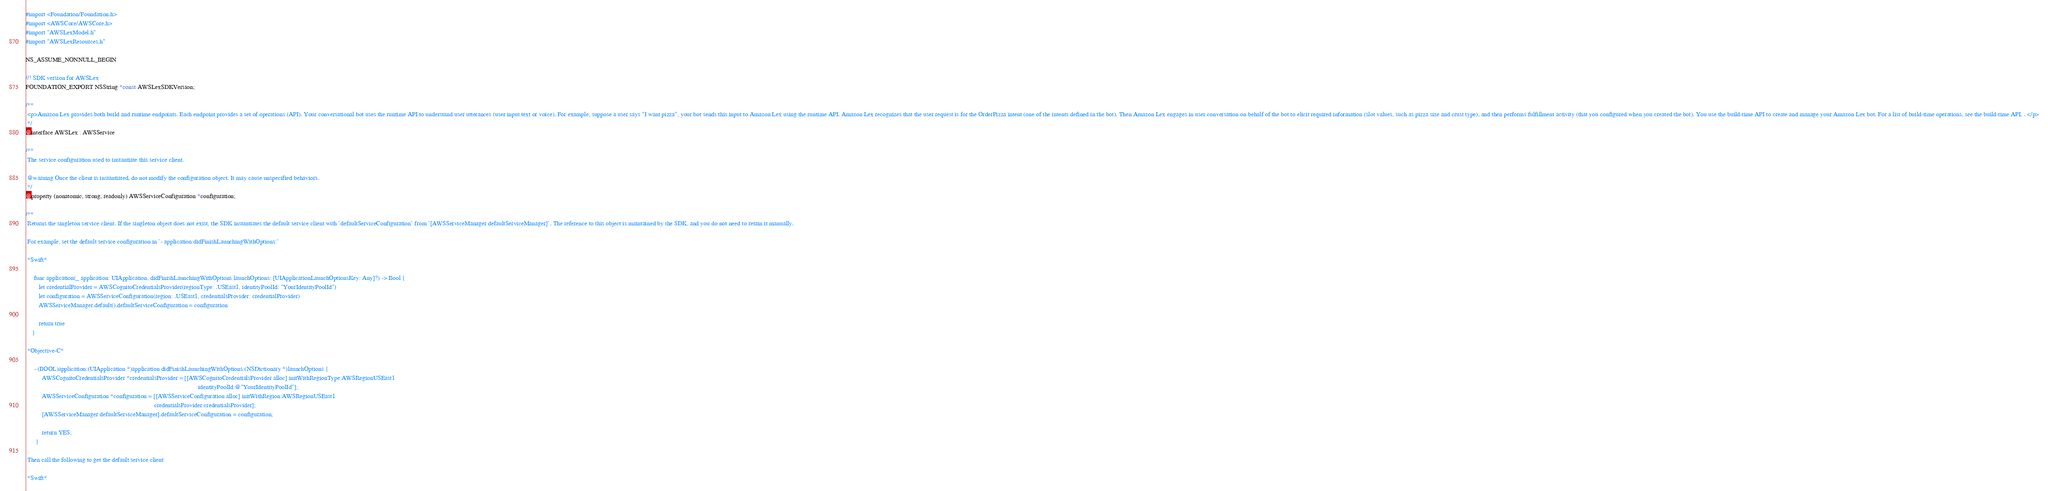Convert code to text. <code><loc_0><loc_0><loc_500><loc_500><_C_>
#import <Foundation/Foundation.h>
#import <AWSCore/AWSCore.h>
#import "AWSLexModel.h"
#import "AWSLexResources.h"

NS_ASSUME_NONNULL_BEGIN

//! SDK version for AWSLex
FOUNDATION_EXPORT NSString *const AWSLexSDKVersion;

/**
 <p>Amazon Lex provides both build and runtime endpoints. Each endpoint provides a set of operations (API). Your conversational bot uses the runtime API to understand user utterances (user input text or voice). For example, suppose a user says "I want pizza", your bot sends this input to Amazon Lex using the runtime API. Amazon Lex recognizes that the user request is for the OrderPizza intent (one of the intents defined in the bot). Then Amazon Lex engages in user conversation on behalf of the bot to elicit required information (slot values, such as pizza size and crust type), and then performs fulfillment activity (that you configured when you created the bot). You use the build-time API to create and manage your Amazon Lex bot. For a list of build-time operations, see the build-time API, . </p>
 */
@interface AWSLex : AWSService

/**
 The service configuration used to instantiate this service client.
 
 @warning Once the client is instantiated, do not modify the configuration object. It may cause unspecified behaviors.
 */
@property (nonatomic, strong, readonly) AWSServiceConfiguration *configuration;

/**
 Returns the singleton service client. If the singleton object does not exist, the SDK instantiates the default service client with `defaultServiceConfiguration` from `[AWSServiceManager defaultServiceManager]`. The reference to this object is maintained by the SDK, and you do not need to retain it manually.

 For example, set the default service configuration in `- application:didFinishLaunchingWithOptions:`
 
 *Swift*

     func application(_ application: UIApplication, didFinishLaunchingWithOptions launchOptions: [UIApplicationLaunchOptionsKey: Any]?) -> Bool {
        let credentialProvider = AWSCognitoCredentialsProvider(regionType: .USEast1, identityPoolId: "YourIdentityPoolId")
        let configuration = AWSServiceConfiguration(region: .USEast1, credentialsProvider: credentialProvider)
        AWSServiceManager.default().defaultServiceConfiguration = configuration
 
        return true
    }

 *Objective-C*

     - (BOOL)application:(UIApplication *)application didFinishLaunchingWithOptions:(NSDictionary *)launchOptions {
          AWSCognitoCredentialsProvider *credentialsProvider = [[AWSCognitoCredentialsProvider alloc] initWithRegionType:AWSRegionUSEast1
                                                                                                          identityPoolId:@"YourIdentityPoolId"];
          AWSServiceConfiguration *configuration = [[AWSServiceConfiguration alloc] initWithRegion:AWSRegionUSEast1
                                                                               credentialsProvider:credentialsProvider];
          [AWSServiceManager defaultServiceManager].defaultServiceConfiguration = configuration;

          return YES;
      }

 Then call the following to get the default service client:

 *Swift*
</code> 